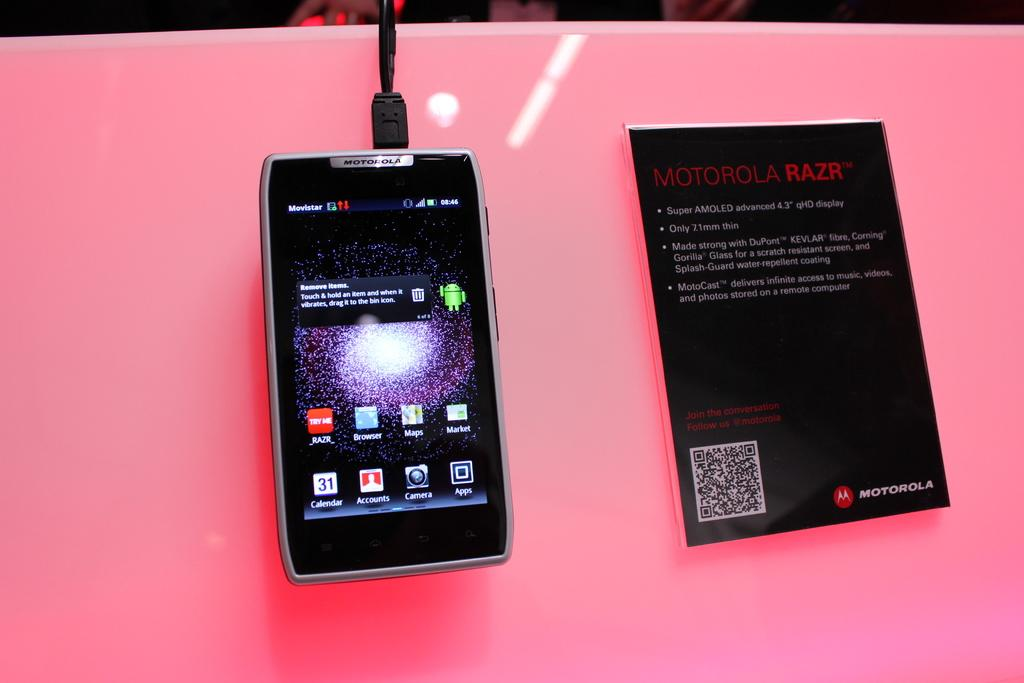<image>
Write a terse but informative summary of the picture. A picture of a smart phone and info sheet that says MOTOROLA RAZR, 